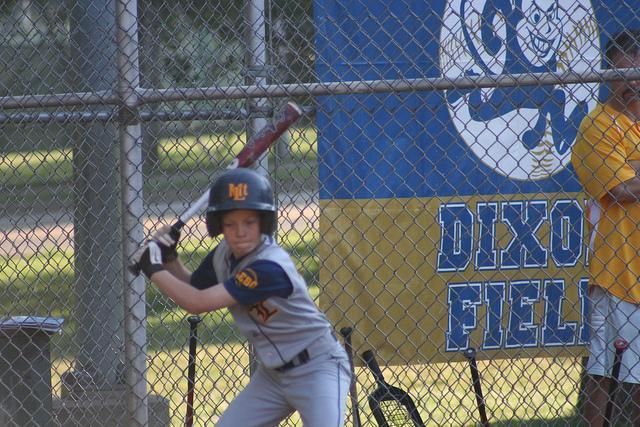How many people can be seen?
Give a very brief answer. 2. How many person is wearing orange color t-shirt?
Give a very brief answer. 0. 